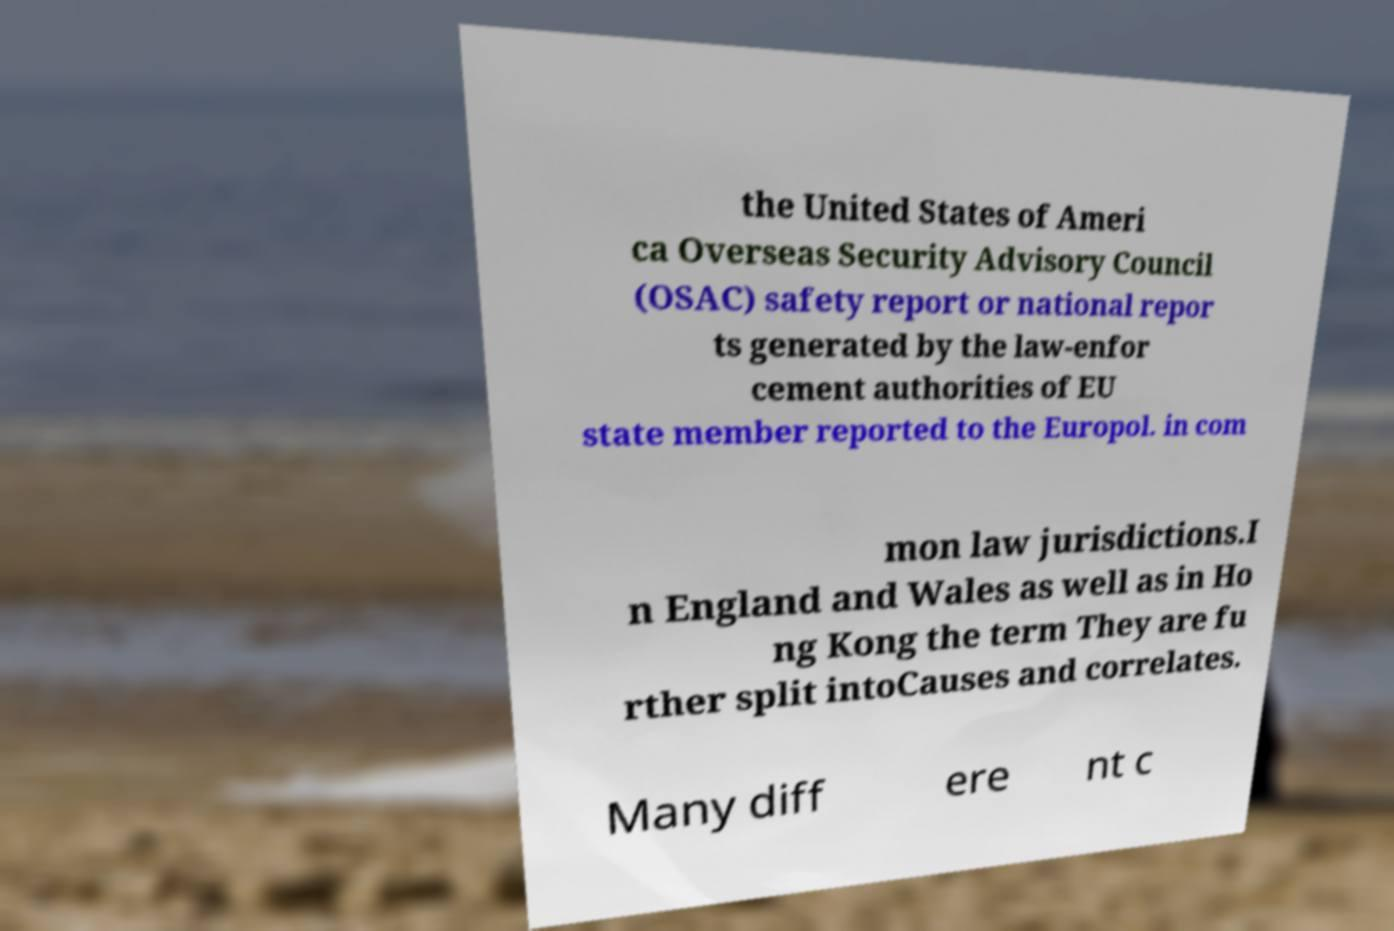Please identify and transcribe the text found in this image. the United States of Ameri ca Overseas Security Advisory Council (OSAC) safety report or national repor ts generated by the law-enfor cement authorities of EU state member reported to the Europol. in com mon law jurisdictions.I n England and Wales as well as in Ho ng Kong the term They are fu rther split intoCauses and correlates. Many diff ere nt c 